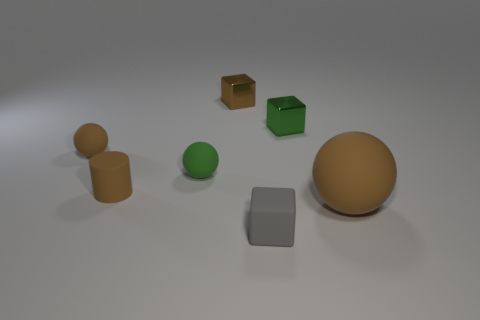Does the green metal object have the same shape as the tiny brown shiny object?
Offer a very short reply. Yes. How many objects are either rubber spheres in front of the matte cylinder or blue things?
Provide a short and direct response. 1. What is the size of the other cube that is made of the same material as the tiny brown cube?
Make the answer very short. Small. How many matte objects are the same color as the small cylinder?
Your response must be concise. 2. How many big objects are brown blocks or green matte things?
Make the answer very short. 0. The matte cylinder that is the same color as the big thing is what size?
Give a very brief answer. Small. Are there any gray objects that have the same material as the small brown cylinder?
Ensure brevity in your answer.  Yes. There is a tiny cube that is in front of the green sphere; what material is it?
Keep it short and to the point. Rubber. Do the tiny sphere that is to the right of the small brown sphere and the small shiny object to the right of the brown block have the same color?
Ensure brevity in your answer.  Yes. There is another rubber ball that is the same size as the green sphere; what is its color?
Give a very brief answer. Brown. 